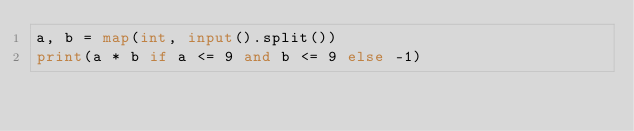Convert code to text. <code><loc_0><loc_0><loc_500><loc_500><_Python_>a, b = map(int, input().split())
print(a * b if a <= 9 and b <= 9 else -1)</code> 